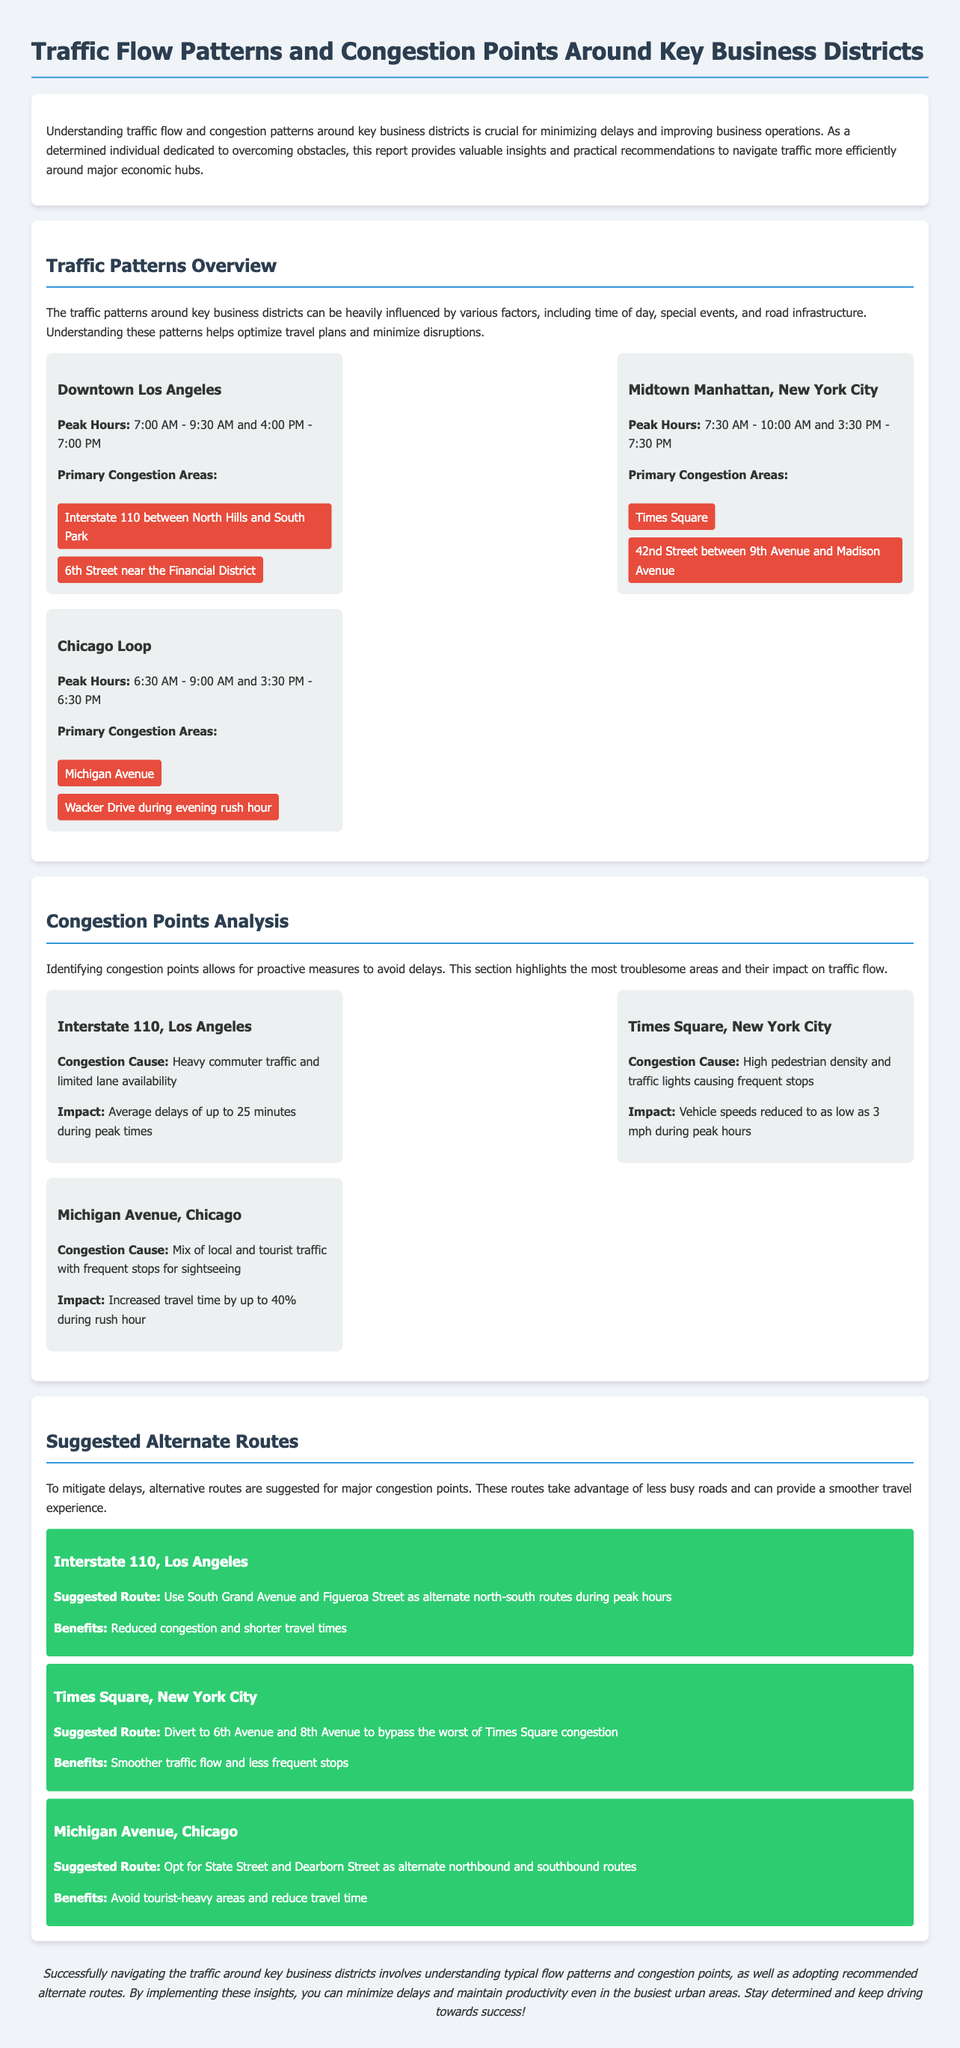What are the peak hours for Downtown Los Angeles? The peak hours for Downtown Los Angeles are mentioned in the document as 7:00 AM - 9:30 AM and 4:00 PM - 7:00 PM.
Answer: 7:00 AM - 9:30 AM and 4:00 PM - 7:00 PM What causes congestion at Times Square in New York City? The document states that the congestion cause at Times Square is high pedestrian density and traffic lights causing frequent stops.
Answer: High pedestrian density and traffic lights What is the alternate route suggested for Michigan Avenue, Chicago? The document provides the alternate route for Michigan Avenue as State Street and Dearborn Street.
Answer: State Street and Dearborn Street What is the average delay time on Interstate 110 during peak hours? According to the document, the average delays on Interstate 110 during peak times can be up to 25 minutes.
Answer: 25 minutes Which district has the lowest vehicle speed in congested conditions? The document indicates that Times Square, New York City, has vehicle speeds reduced to as low as 3 mph during peak hours.
Answer: Times Square, New York City What is the impact of congestion in Michigan Avenue, Chicago? The document states that the impact of congestion on Michigan Avenue can increase travel time by up to 40% during rush hour.
Answer: Up to 40% What are the primary congestion areas in Midtown Manhattan? The document lists the primary congestion areas as Times Square and 42nd Street between 9th Avenue and Madison Avenue.
Answer: Times Square and 42nd Street between 9th Avenue and Madison Avenue Which business district experiences peak hours starting at 6:30 AM? The Chicago Loop is the business district that experiences peak hours starting at 6:30 AM.
Answer: Chicago Loop What is the suggested benefit of using South Grand Avenue and Figueroa Street? The document states that these alternate routes provide reduced congestion and shorter travel times.
Answer: Reduced congestion and shorter travel times 